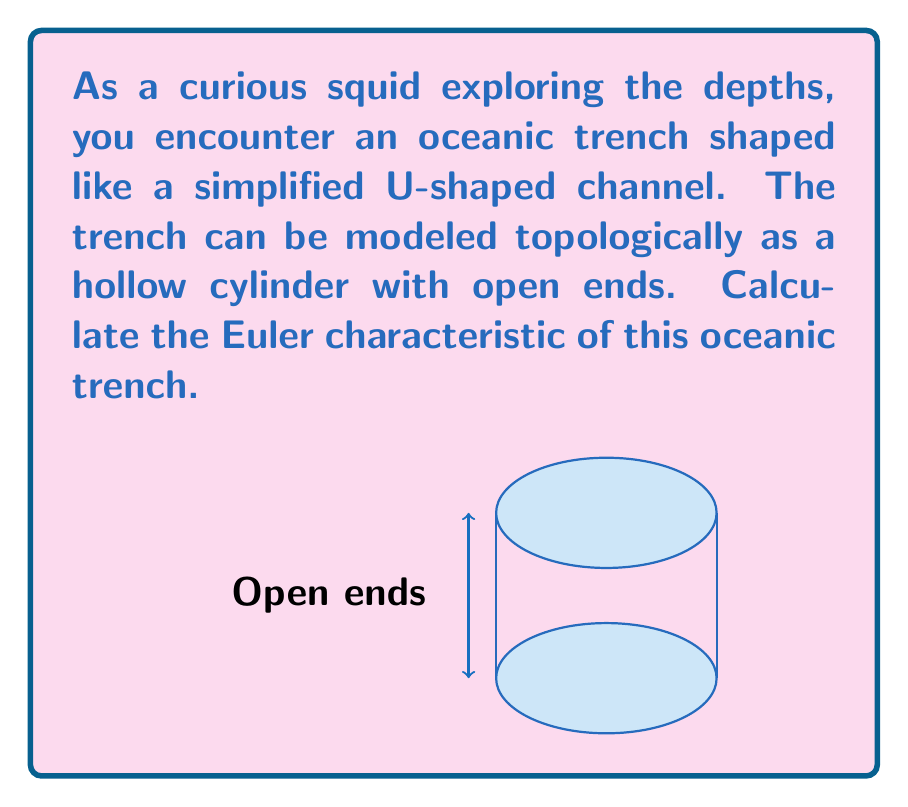Teach me how to tackle this problem. To calculate the Euler characteristic of the oceanic trench, we need to follow these steps:

1) Recall the formula for the Euler characteristic:
   $$\chi = V - E + F$$
   where $V$ is the number of vertices, $E$ is the number of edges, and $F$ is the number of faces.

2) Analyze the topological structure of the trench:
   - It is a hollow cylinder with both ends open.
   - Topologically, this is equivalent to a cylindrical surface without top and bottom faces.

3) Count the components:
   - Vertices (V): The cylinder has no distinct vertices. $V = 0$
   - Edges (E): The cylinder has no distinct edges. $E = 0$
   - Faces (F): The cylinder has one curved face (the side of the cylinder). $F = 1$

4) Apply the Euler characteristic formula:
   $$\chi = V - E + F = 0 - 0 + 1 = 1$$

5) Interpret the result:
   The Euler characteristic of 1 confirms that this shape is topologically equivalent to an open cylinder or an annulus, which has the same Euler characteristic.
Answer: $\chi = 1$ 